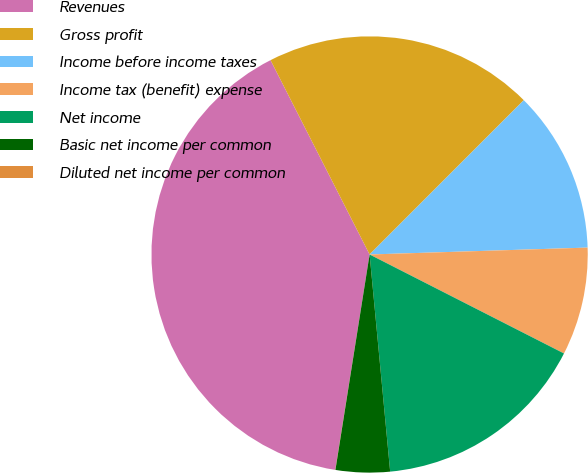<chart> <loc_0><loc_0><loc_500><loc_500><pie_chart><fcel>Revenues<fcel>Gross profit<fcel>Income before income taxes<fcel>Income tax (benefit) expense<fcel>Net income<fcel>Basic net income per common<fcel>Diluted net income per common<nl><fcel>39.98%<fcel>20.0%<fcel>12.0%<fcel>8.0%<fcel>16.0%<fcel>4.01%<fcel>0.01%<nl></chart> 